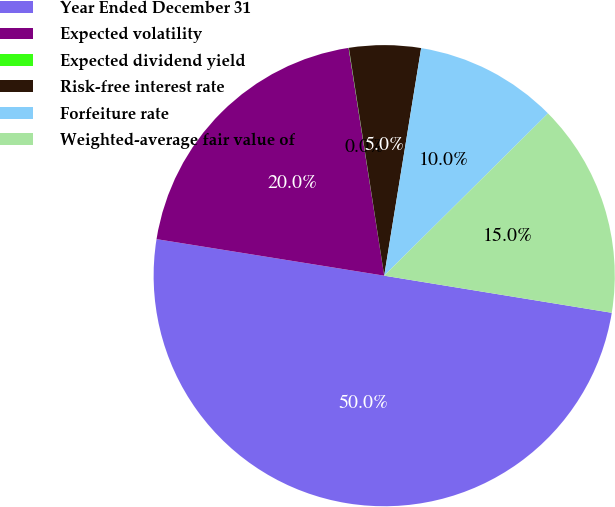<chart> <loc_0><loc_0><loc_500><loc_500><pie_chart><fcel>Year Ended December 31<fcel>Expected volatility<fcel>Expected dividend yield<fcel>Risk-free interest rate<fcel>Forfeiture rate<fcel>Weighted-average fair value of<nl><fcel>49.96%<fcel>20.0%<fcel>0.02%<fcel>5.01%<fcel>10.01%<fcel>15.0%<nl></chart> 